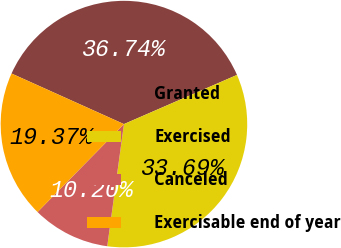Convert chart. <chart><loc_0><loc_0><loc_500><loc_500><pie_chart><fcel>Granted<fcel>Exercised<fcel>Canceled<fcel>Exercisable end of year<nl><fcel>36.74%<fcel>33.69%<fcel>10.2%<fcel>19.37%<nl></chart> 